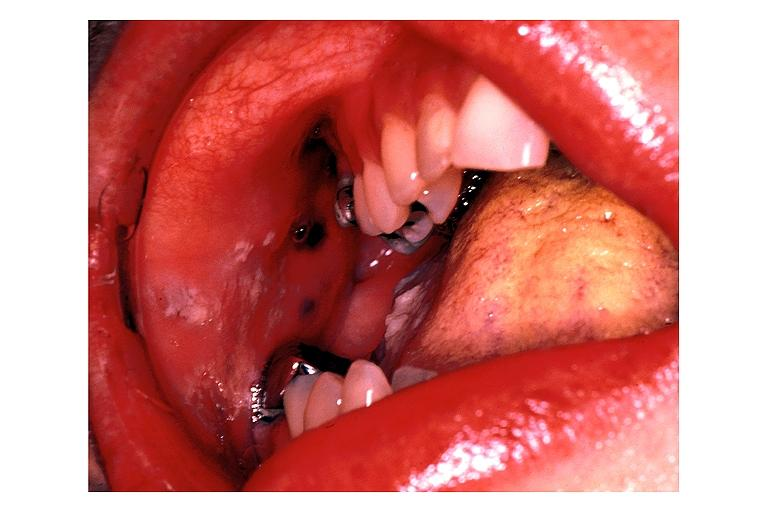does this image show peutz geghers syndrome?
Answer the question using a single word or phrase. Yes 